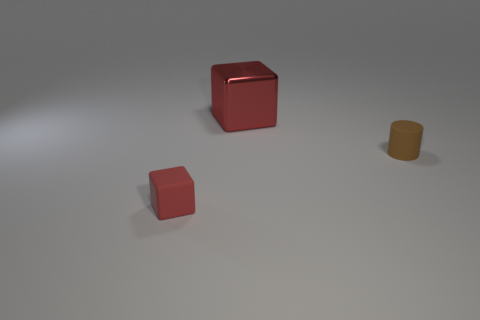Subtract all red blocks. How many were subtracted if there are1red blocks left? 1 Subtract all cyan blocks. Subtract all brown cylinders. How many blocks are left? 2 Add 2 gray rubber things. How many objects exist? 5 Subtract all cylinders. How many objects are left? 2 Subtract 0 green cylinders. How many objects are left? 3 Subtract all gray objects. Subtract all red cubes. How many objects are left? 1 Add 3 small brown rubber cylinders. How many small brown rubber cylinders are left? 4 Add 2 big red metal objects. How many big red metal objects exist? 3 